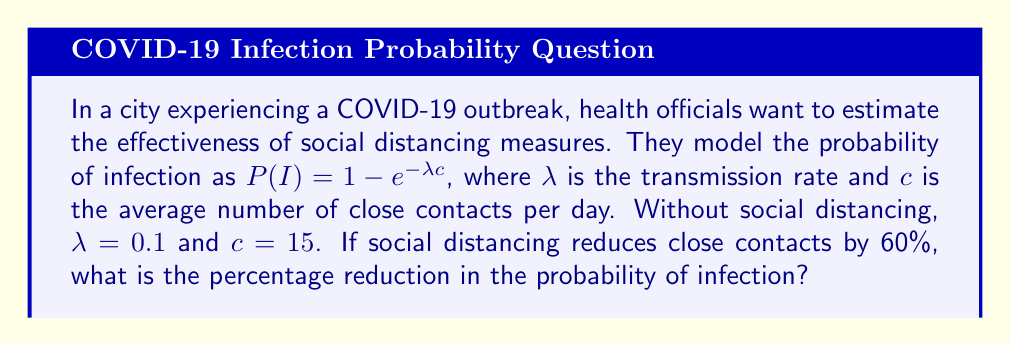Show me your answer to this math problem. To solve this problem, we'll follow these steps:

1) First, calculate the probability of infection without social distancing:
   $P(I)_{before} = 1 - e^{-\lambda c} = 1 - e^{-0.1 \times 15} = 1 - e^{-1.5}$

2) Calculate this value:
   $P(I)_{before} = 1 - e^{-1.5} \approx 0.7769$ or about 77.69%

3) Now, with social distancing, contacts are reduced by 60%:
   $c_{new} = 15 \times (1 - 0.6) = 15 \times 0.4 = 6$

4) Calculate the new probability of infection:
   $P(I)_{after} = 1 - e^{-\lambda c_{new}} = 1 - e^{-0.1 \times 6} = 1 - e^{-0.6}$

5) Calculate this value:
   $P(I)_{after} = 1 - e^{-0.6} \approx 0.4512$ or about 45.12%

6) Calculate the percentage reduction:
   Reduction = $\frac{P(I)_{before} - P(I)_{after}}{P(I)_{before}} \times 100\%$
   
   $= \frac{0.7769 - 0.4512}{0.7769} \times 100\% \approx 41.92\%$

Therefore, social distancing measures reduce the probability of infection by approximately 41.92%.
Answer: 41.92% 